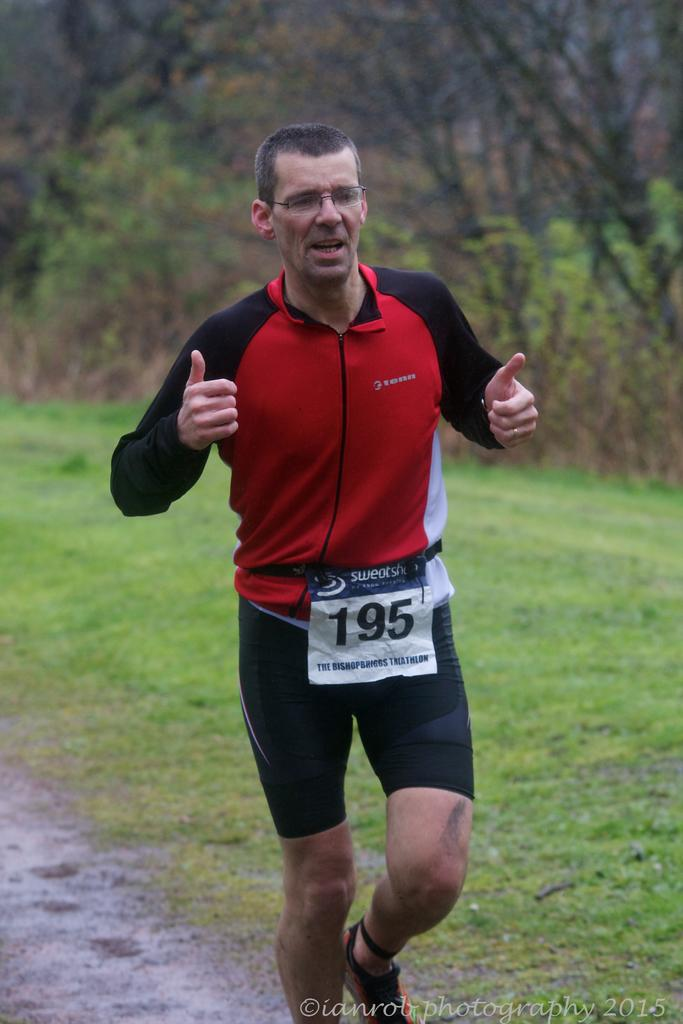Who is present in the image? There is a person in the image. What can be seen on the person's face? The person is wearing specs. What number is visible on the person's chest? The person has a chest number. What type of terrain is visible on the ground in the image? There is grass on the ground in the image. What can be seen in the distance in the image? There are trees in the background of the image. Where is the text located in the image? There is text written in the right bottom corner of the image. What type of argument is the person having with their aunt in the image? There is no argument or aunt present in the image; it only features a person with a chest number and specs, surrounded by grass and trees. What type of board is the person using to play a game in the image? There is no board or game present in the image; it only features a person with a chest number and specs, surrounded by grass and trees. 